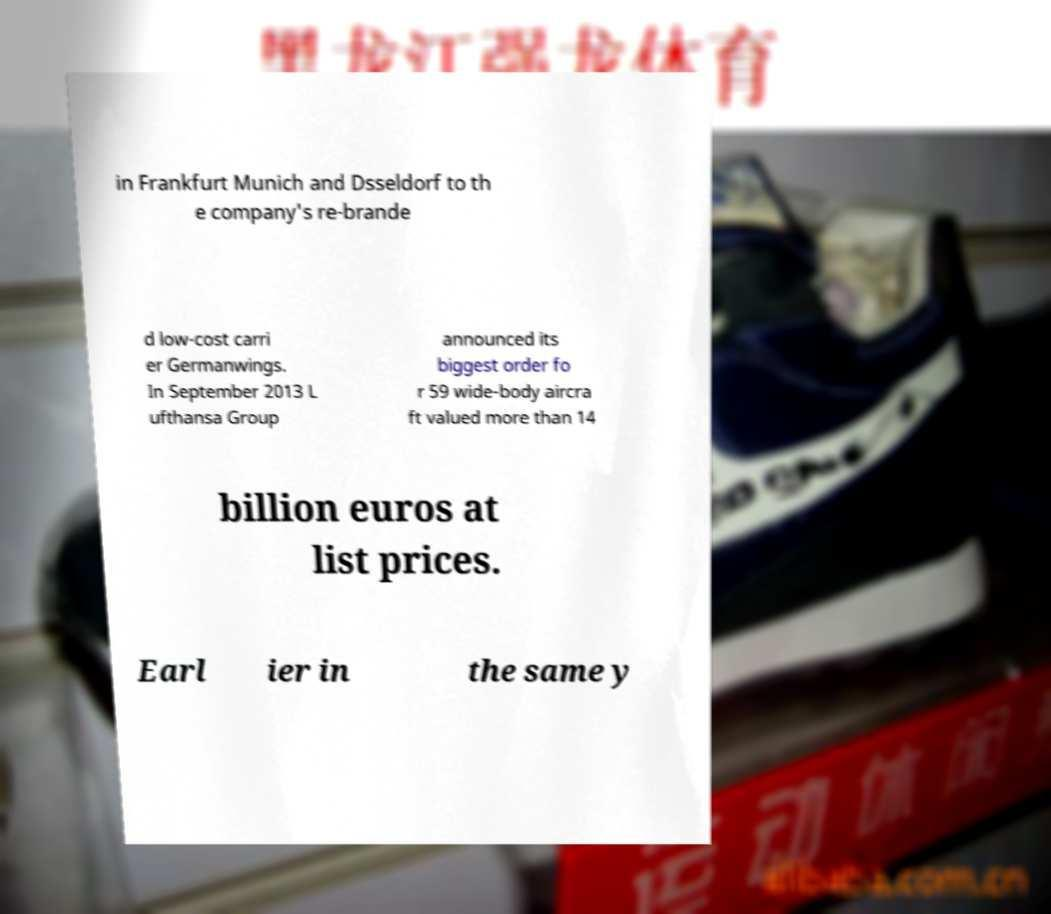Please read and relay the text visible in this image. What does it say? in Frankfurt Munich and Dsseldorf to th e company's re-brande d low-cost carri er Germanwings. In September 2013 L ufthansa Group announced its biggest order fo r 59 wide-body aircra ft valued more than 14 billion euros at list prices. Earl ier in the same y 